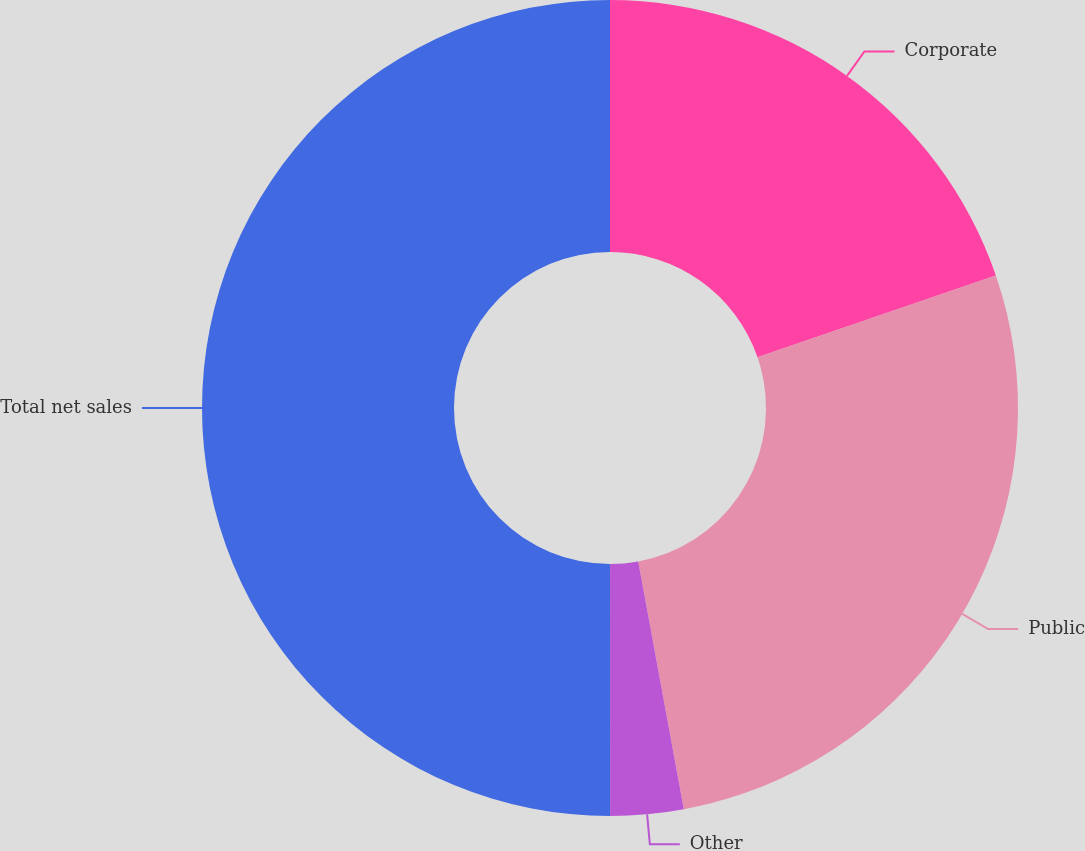Convert chart. <chart><loc_0><loc_0><loc_500><loc_500><pie_chart><fcel>Corporate<fcel>Public<fcel>Other<fcel>Total net sales<nl><fcel>19.73%<fcel>27.37%<fcel>2.89%<fcel>50.0%<nl></chart> 